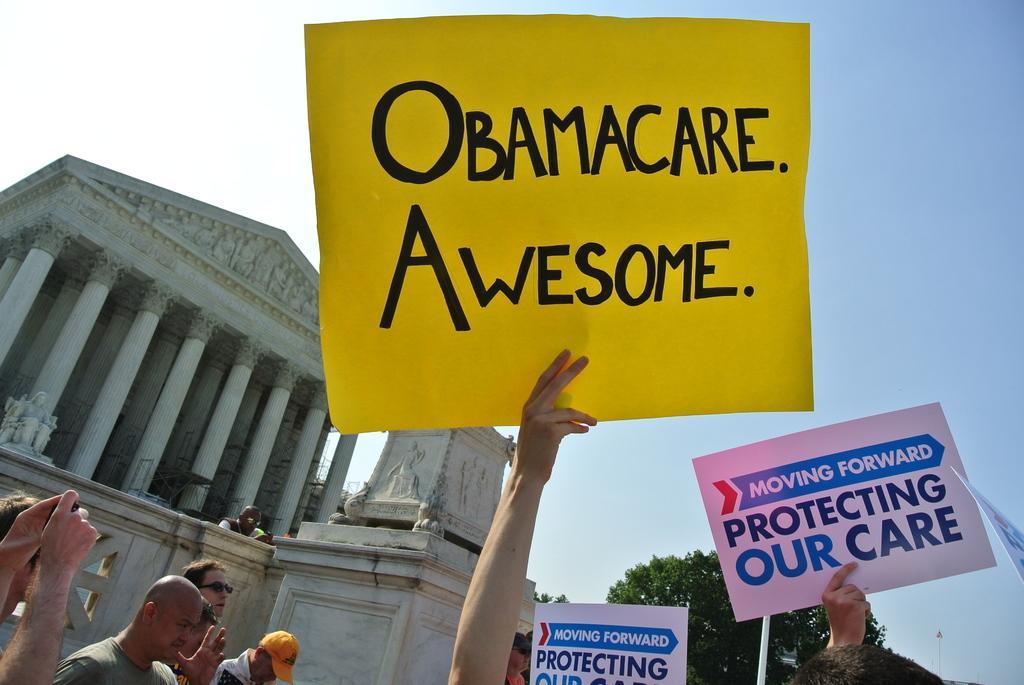Could you give a brief overview of what you see in this image? In the picture we can see some people are holding some boards written on it as Obama care awesome and besides them, we can see some people are also standing, and behind them, we can see the white house and beside it we can see trees and a sky behind it. 